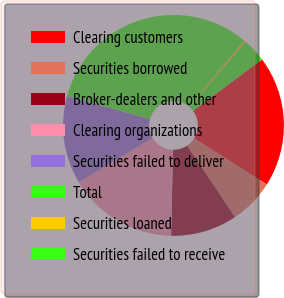Convert chart. <chart><loc_0><loc_0><loc_500><loc_500><pie_chart><fcel>Clearing customers<fcel>Securities borrowed<fcel>Broker-dealers and other<fcel>Clearing organizations<fcel>Securities failed to deliver<fcel>Total<fcel>Securities loaned<fcel>Securities failed to receive<nl><fcel>19.19%<fcel>6.6%<fcel>9.75%<fcel>16.04%<fcel>12.89%<fcel>31.78%<fcel>0.3%<fcel>3.45%<nl></chart> 